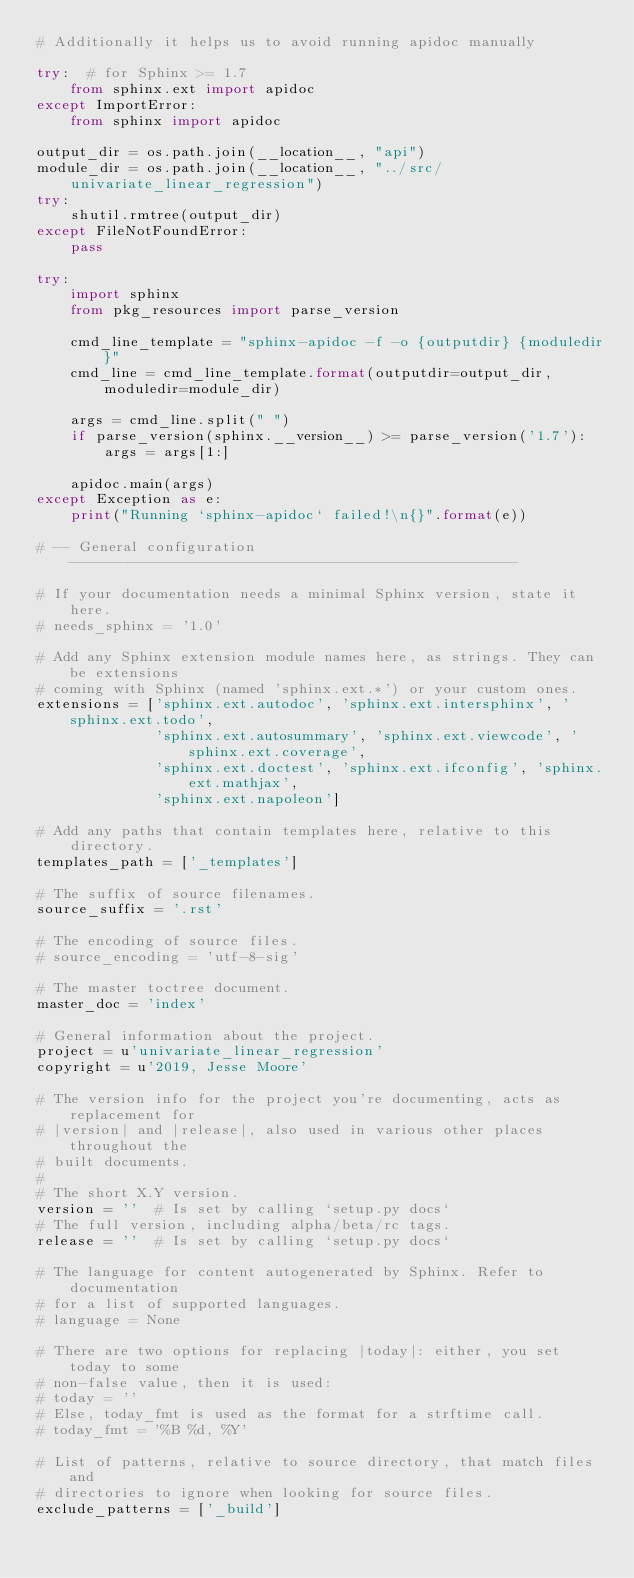<code> <loc_0><loc_0><loc_500><loc_500><_Python_># Additionally it helps us to avoid running apidoc manually

try:  # for Sphinx >= 1.7
    from sphinx.ext import apidoc
except ImportError:
    from sphinx import apidoc

output_dir = os.path.join(__location__, "api")
module_dir = os.path.join(__location__, "../src/univariate_linear_regression")
try:
    shutil.rmtree(output_dir)
except FileNotFoundError:
    pass

try:
    import sphinx
    from pkg_resources import parse_version

    cmd_line_template = "sphinx-apidoc -f -o {outputdir} {moduledir}"
    cmd_line = cmd_line_template.format(outputdir=output_dir, moduledir=module_dir)

    args = cmd_line.split(" ")
    if parse_version(sphinx.__version__) >= parse_version('1.7'):
        args = args[1:]

    apidoc.main(args)
except Exception as e:
    print("Running `sphinx-apidoc` failed!\n{}".format(e))

# -- General configuration -----------------------------------------------------

# If your documentation needs a minimal Sphinx version, state it here.
# needs_sphinx = '1.0'

# Add any Sphinx extension module names here, as strings. They can be extensions
# coming with Sphinx (named 'sphinx.ext.*') or your custom ones.
extensions = ['sphinx.ext.autodoc', 'sphinx.ext.intersphinx', 'sphinx.ext.todo',
              'sphinx.ext.autosummary', 'sphinx.ext.viewcode', 'sphinx.ext.coverage',
              'sphinx.ext.doctest', 'sphinx.ext.ifconfig', 'sphinx.ext.mathjax',
              'sphinx.ext.napoleon']

# Add any paths that contain templates here, relative to this directory.
templates_path = ['_templates']

# The suffix of source filenames.
source_suffix = '.rst'

# The encoding of source files.
# source_encoding = 'utf-8-sig'

# The master toctree document.
master_doc = 'index'

# General information about the project.
project = u'univariate_linear_regression'
copyright = u'2019, Jesse Moore'

# The version info for the project you're documenting, acts as replacement for
# |version| and |release|, also used in various other places throughout the
# built documents.
#
# The short X.Y version.
version = ''  # Is set by calling `setup.py docs`
# The full version, including alpha/beta/rc tags.
release = ''  # Is set by calling `setup.py docs`

# The language for content autogenerated by Sphinx. Refer to documentation
# for a list of supported languages.
# language = None

# There are two options for replacing |today|: either, you set today to some
# non-false value, then it is used:
# today = ''
# Else, today_fmt is used as the format for a strftime call.
# today_fmt = '%B %d, %Y'

# List of patterns, relative to source directory, that match files and
# directories to ignore when looking for source files.
exclude_patterns = ['_build']
</code> 